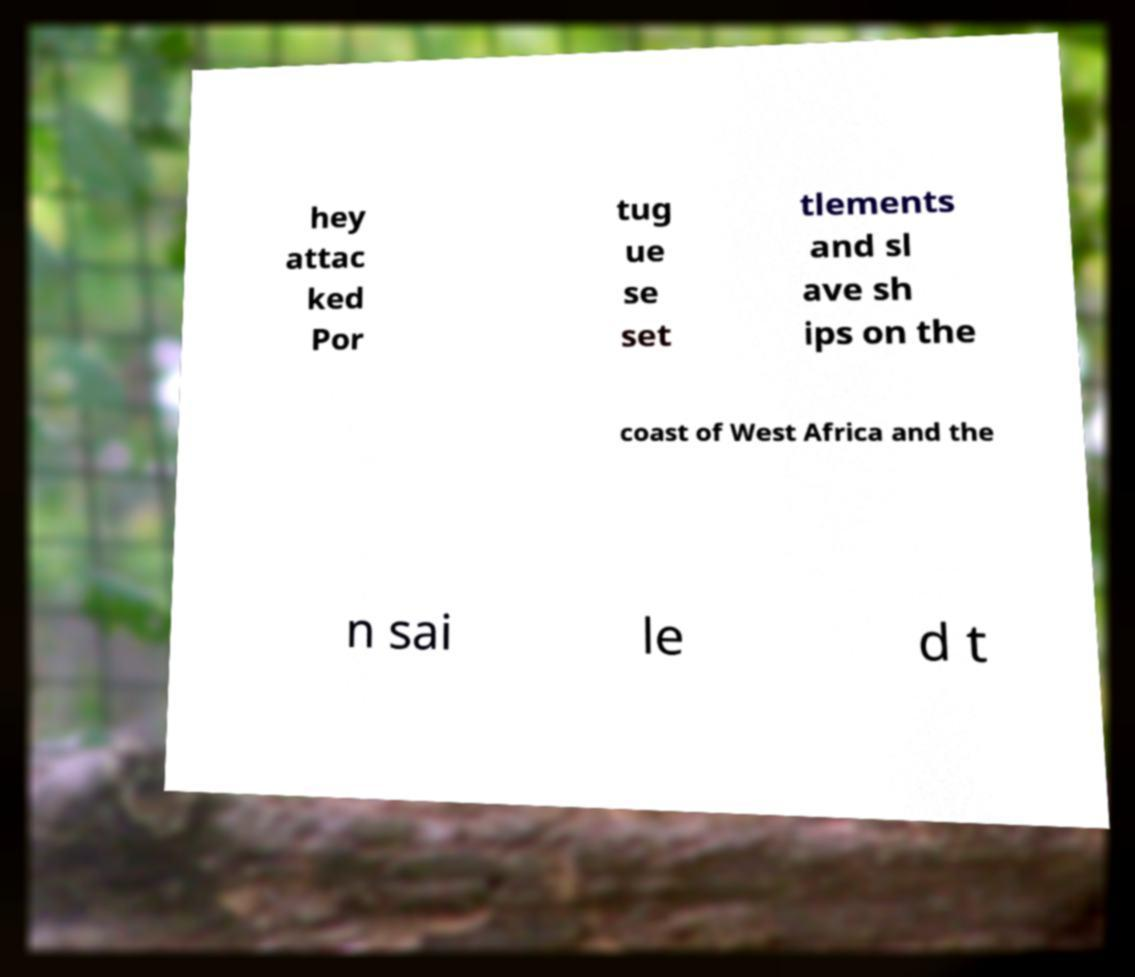Please identify and transcribe the text found in this image. hey attac ked Por tug ue se set tlements and sl ave sh ips on the coast of West Africa and the n sai le d t 